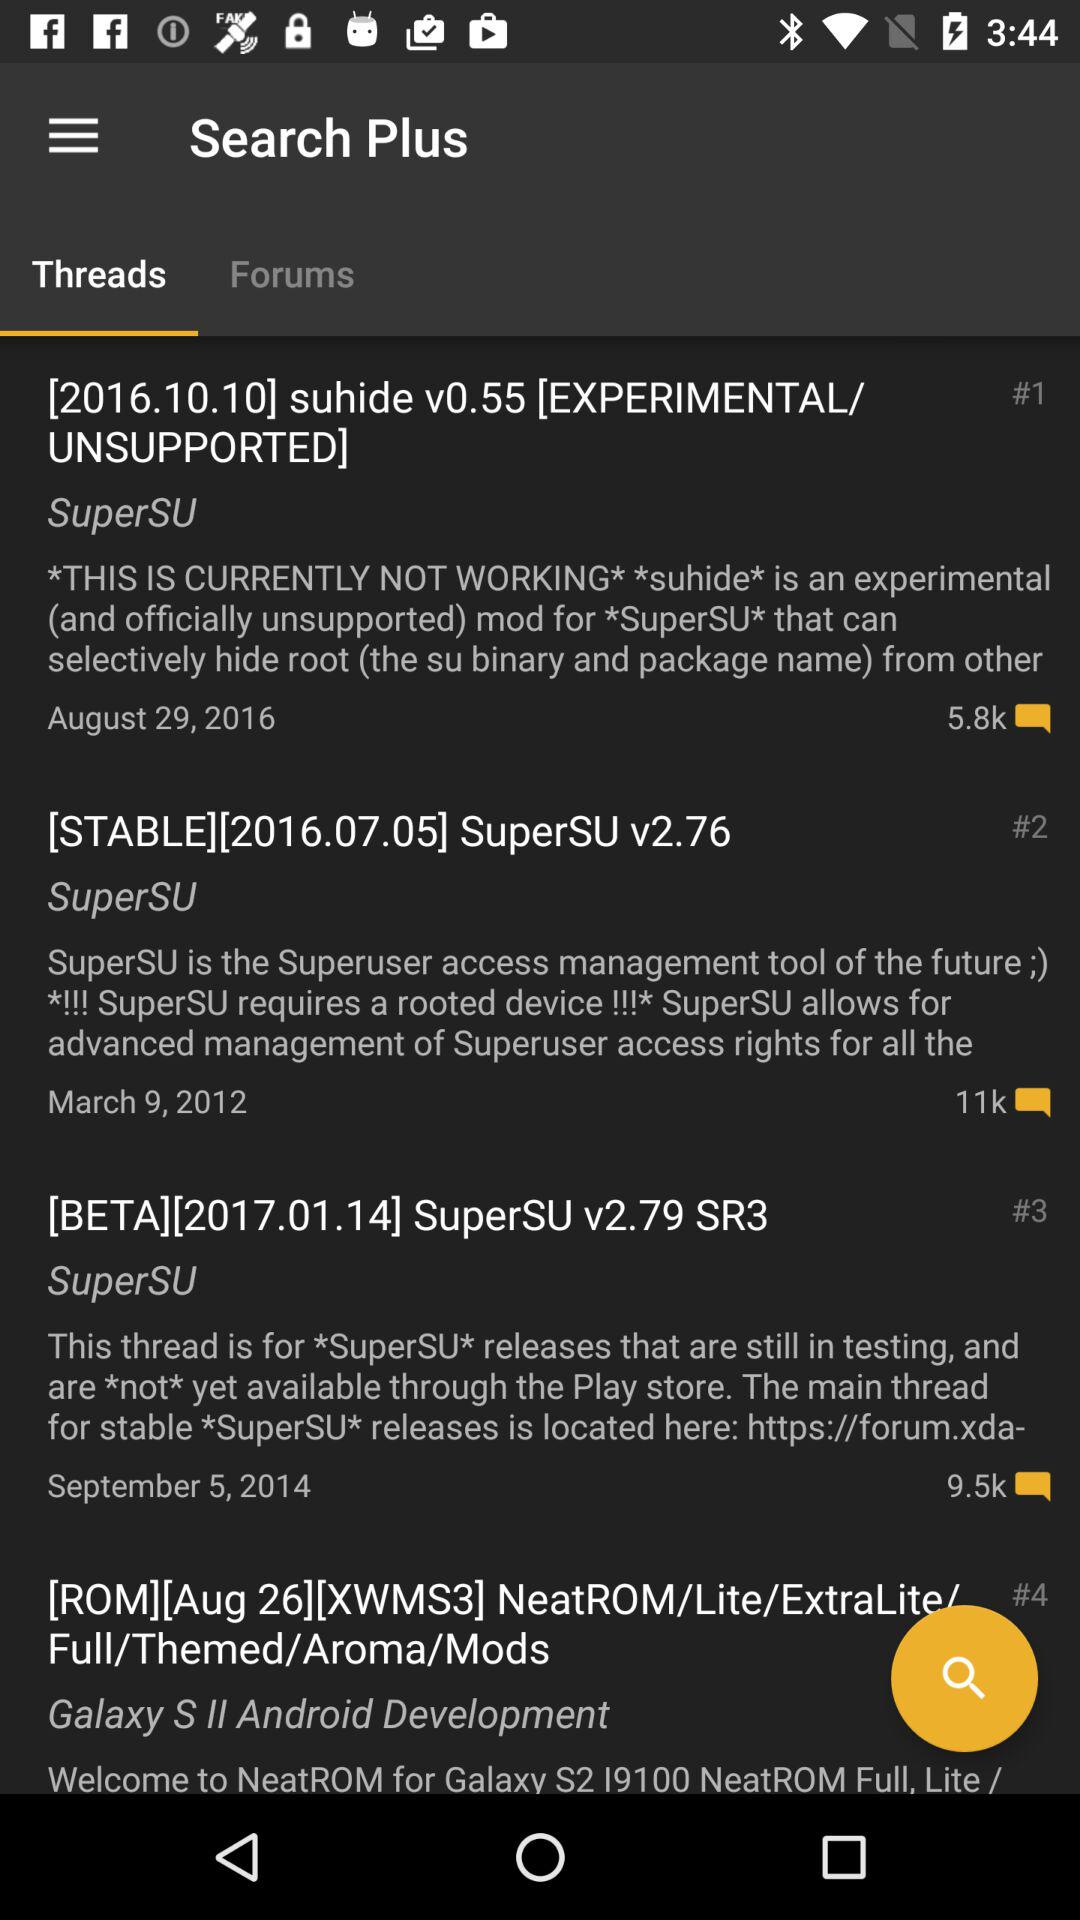How many threads are there for SuperSU?
Answer the question using a single word or phrase. 3 